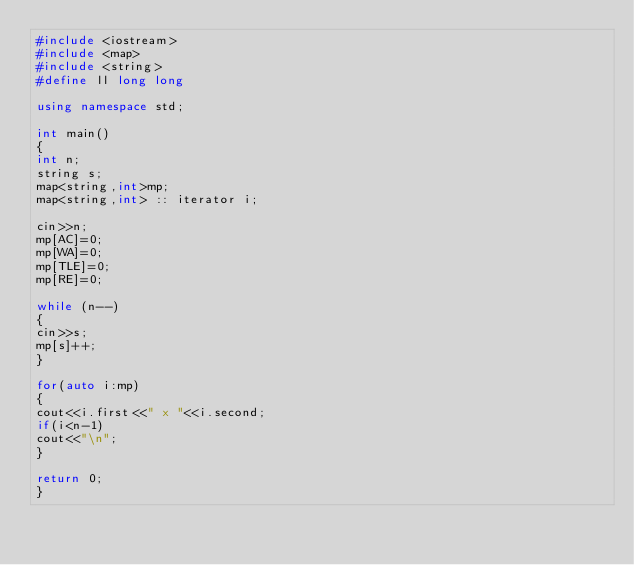<code> <loc_0><loc_0><loc_500><loc_500><_C++_>#include <iostream>
#include <map>
#include <string>
#define ll long long

using namespace std;

int main()
{
int n;
string s;
map<string,int>mp;
map<string,int> :: iterator i;

cin>>n;
mp[AC]=0;
mp[WA]=0;
mp[TLE]=0;
mp[RE]=0;

while (n--)
{
cin>>s;
mp[s]++;
}

for(auto i:mp)
{
cout<<i.first<<" x "<<i.second;
if(i<n-1)
cout<<"\n";
}

return 0;
}</code> 